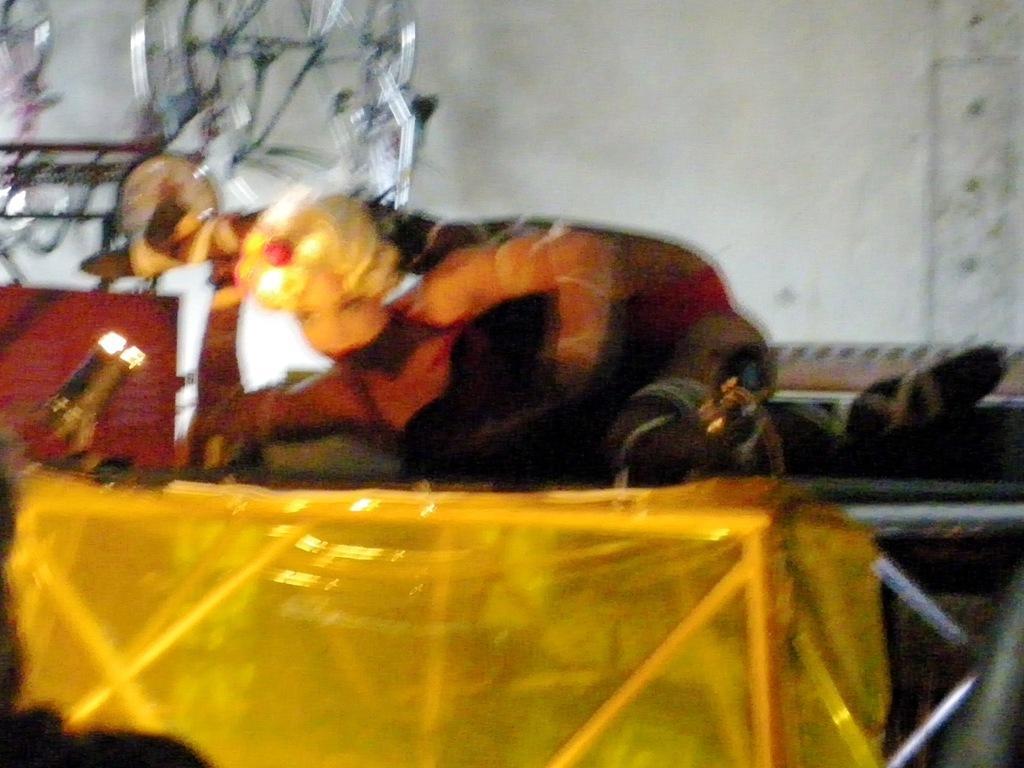Please provide a concise description of this image. This is a blur image. In this image we can see a lady on a platform. In the background there is a wall. Also there is a light on the left side. And there are few other objects. 